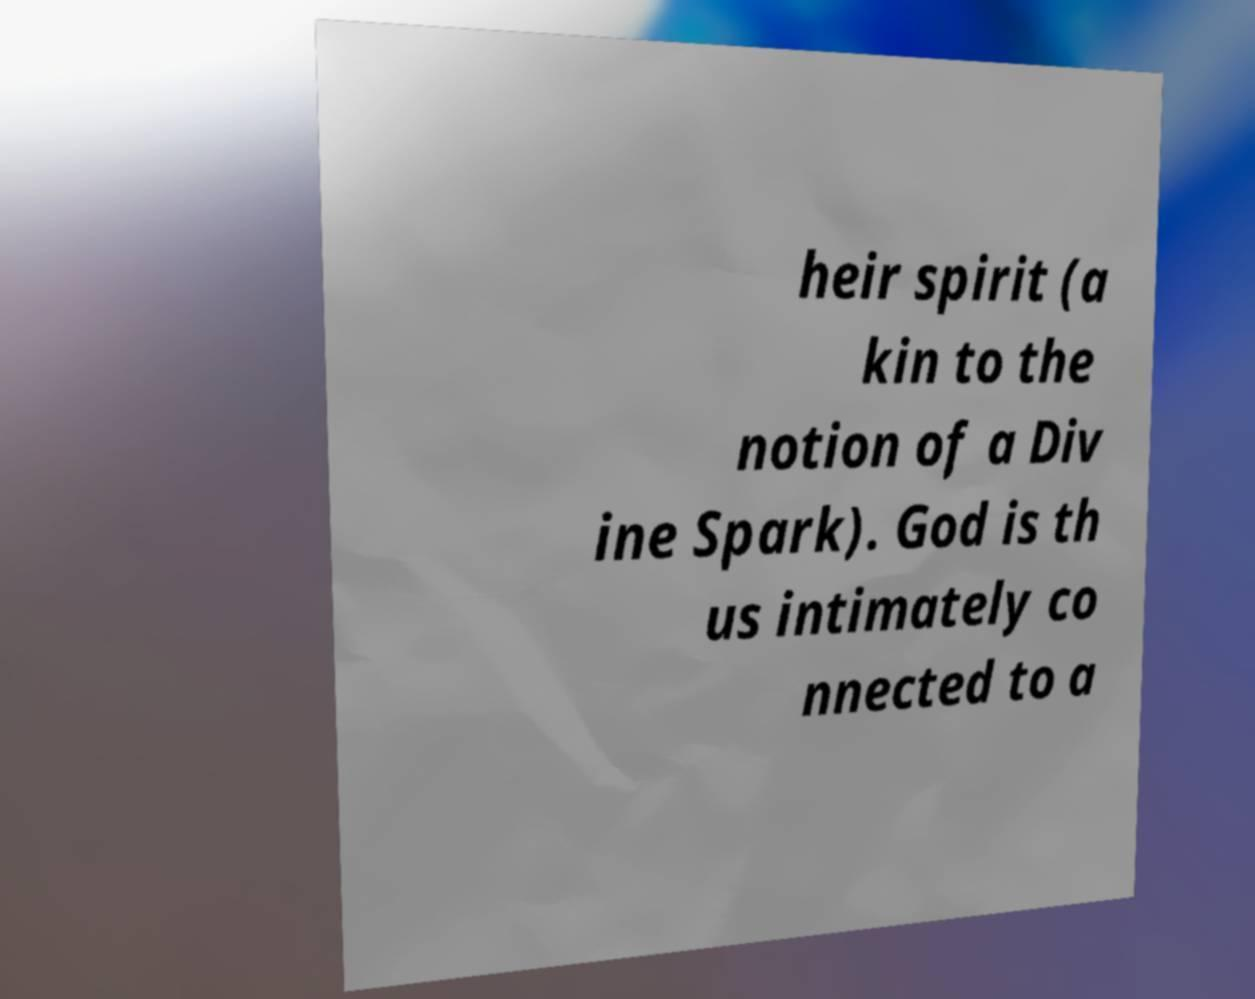Could you assist in decoding the text presented in this image and type it out clearly? heir spirit (a kin to the notion of a Div ine Spark). God is th us intimately co nnected to a 